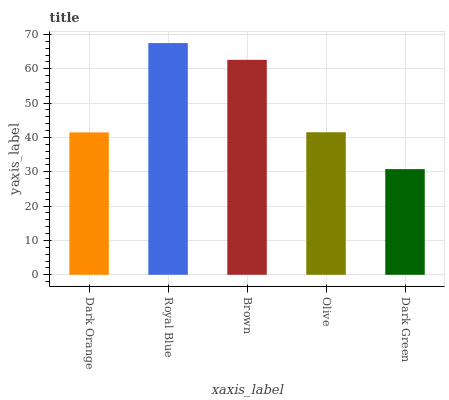Is Brown the minimum?
Answer yes or no. No. Is Brown the maximum?
Answer yes or no. No. Is Royal Blue greater than Brown?
Answer yes or no. Yes. Is Brown less than Royal Blue?
Answer yes or no. Yes. Is Brown greater than Royal Blue?
Answer yes or no. No. Is Royal Blue less than Brown?
Answer yes or no. No. Is Olive the high median?
Answer yes or no. Yes. Is Olive the low median?
Answer yes or no. Yes. Is Royal Blue the high median?
Answer yes or no. No. Is Royal Blue the low median?
Answer yes or no. No. 